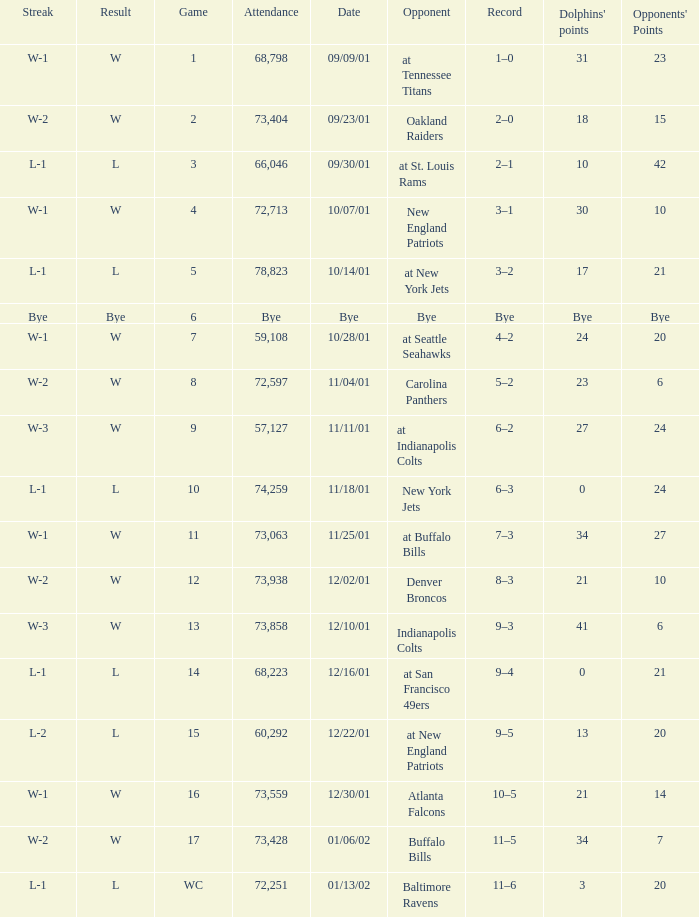How many attended the game with an opponent of bye? Bye. 